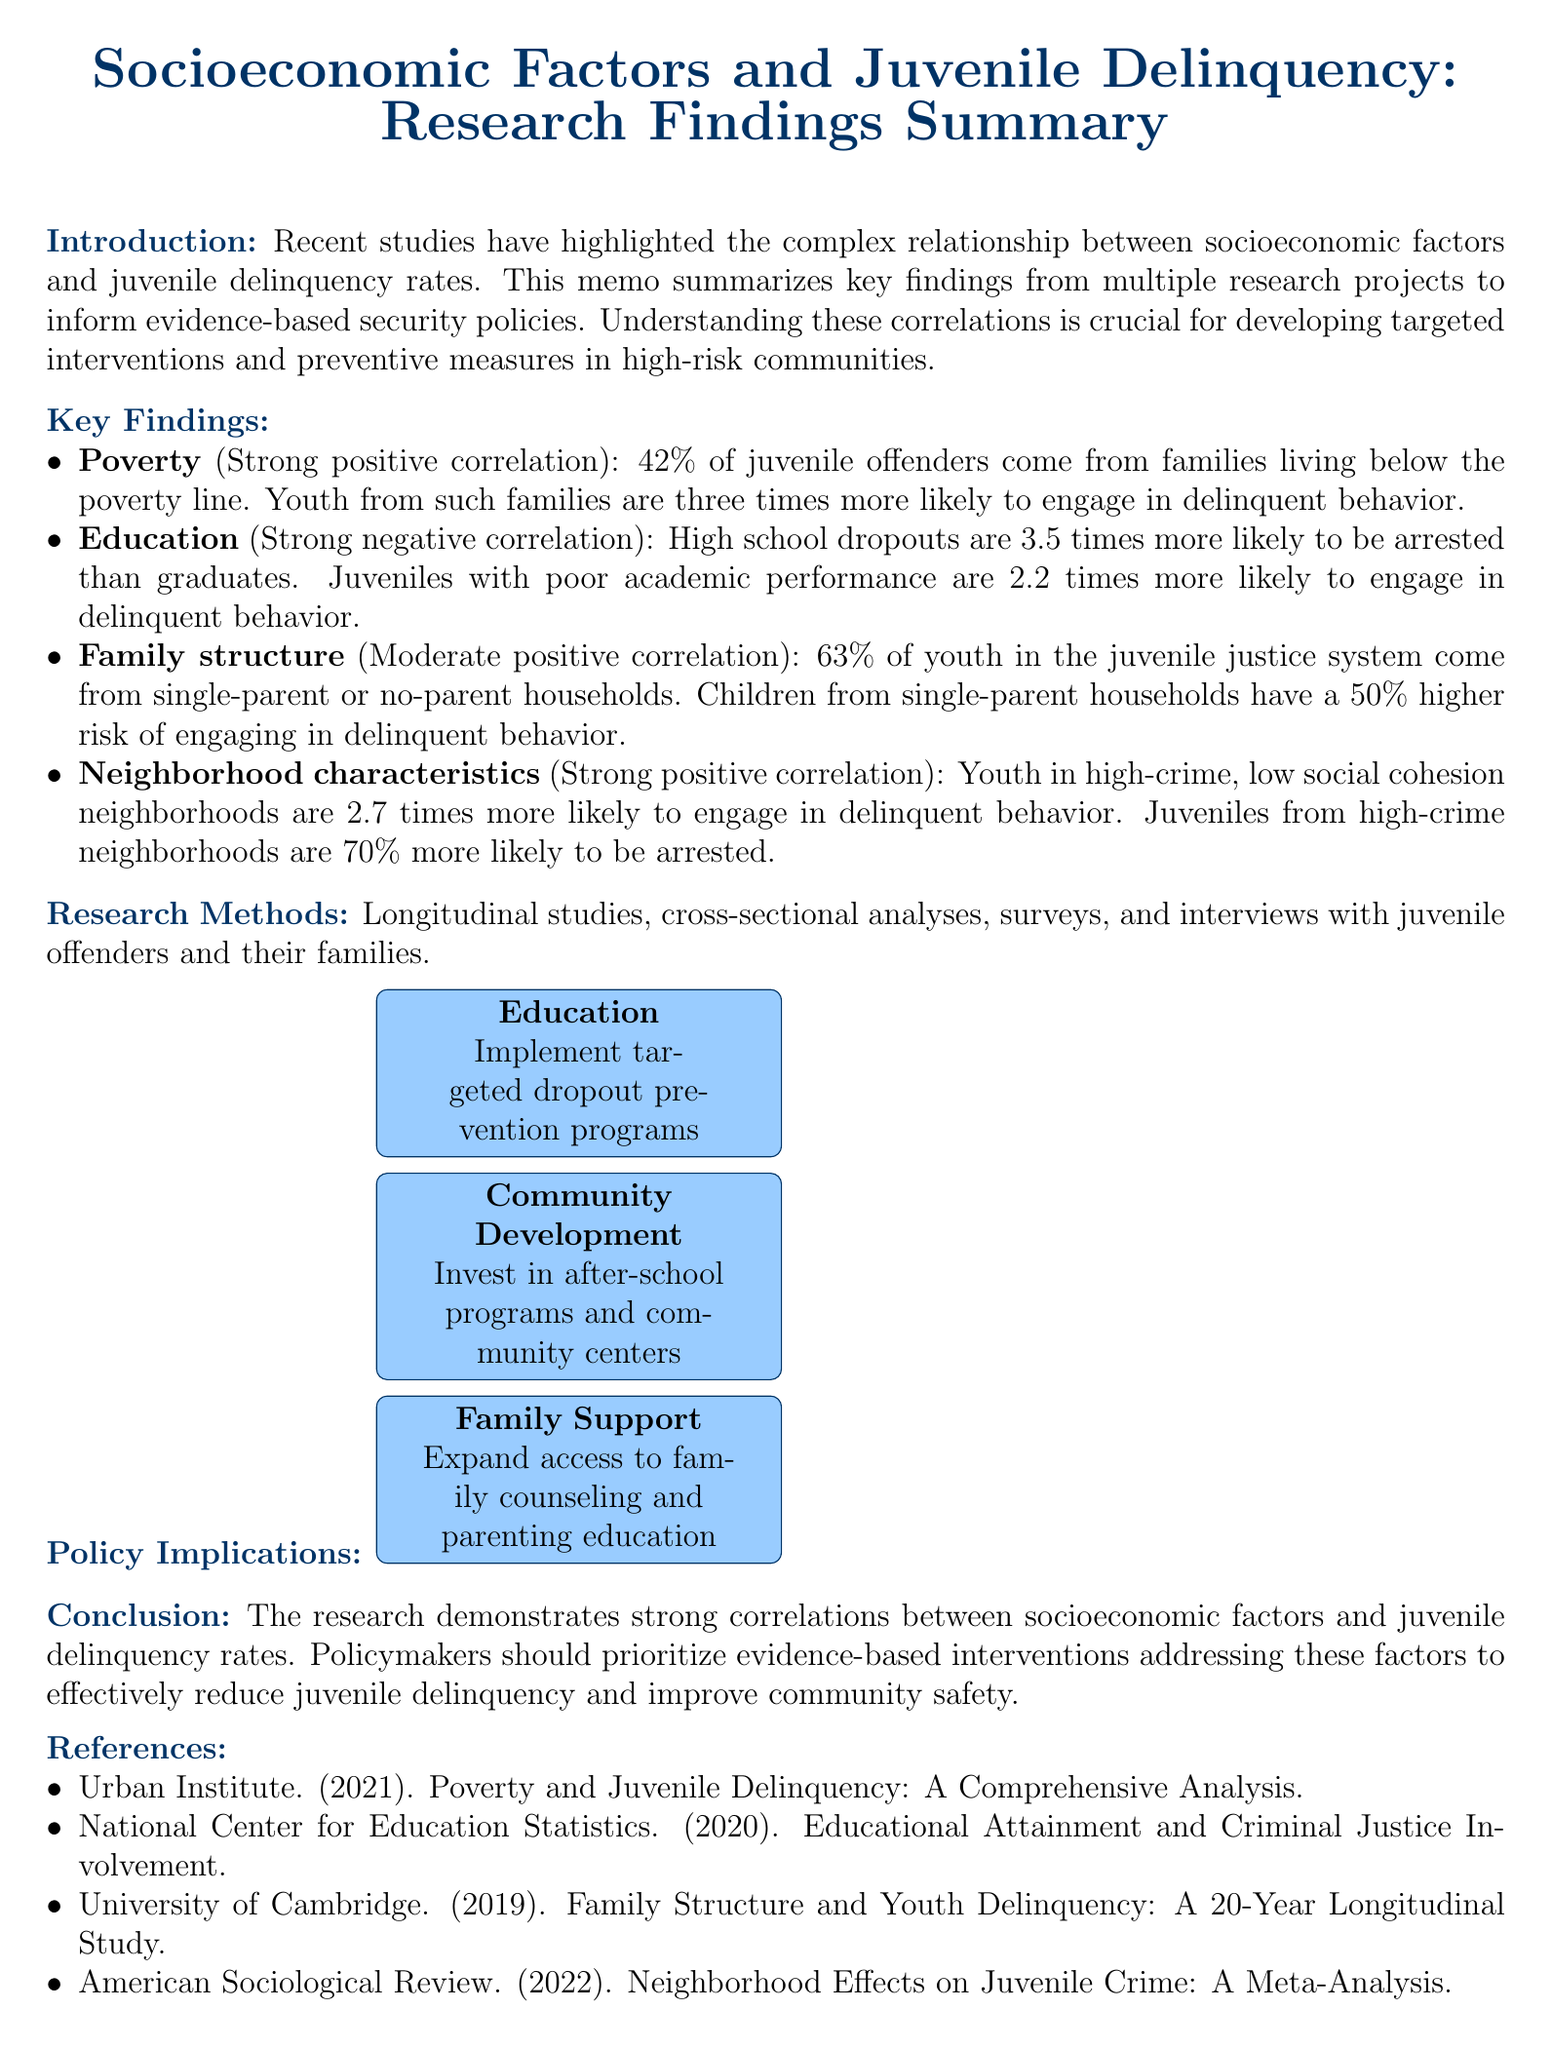What is the title of the memo? The title of the memo is presented at the beginning of the document.
Answer: Socioeconomic Factors and Juvenile Delinquency: Research Findings Summary Which factor has a strong positive correlation with juvenile delinquency? The memo lists several factors and their correlations, indicating which factors are correlated with juvenile delinquency.
Answer: Poverty What percentage of juvenile offenders come from families below the poverty line? This percentage is provided as a statistic in the key findings section.
Answer: 42% What is the expected impact of implementing dropout prevention programs? This information is given in the policy implications section regarding education interventions.
Answer: 15% reduction in juvenile delinquency rates over 5 years How much more likely are high school dropouts to be arrested than graduates? The memo provides a specific statistic in the findings related to education and delinquency.
Answer: 3.5 times What type of studies were primarily used in the research methods? The memo outlines various methods used in the research, highlighting common types.
Answer: Longitudinal studies Which organization conducted a study on family structure and youth delinquency? The references mention organizations responsible for specific studies mentioned in the findings.
Answer: University of Cambridge What is the relationship between family structure and juvenile delinquency rates? The memo outlines findings related to family structure, indicating its correlation with delinquency.
Answer: Moderate positive 